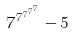Convert formula to latex. <formula><loc_0><loc_0><loc_500><loc_500>7 ^ { 7 ^ { 7 ^ { 7 ^ { 7 } } } } - 5</formula> 